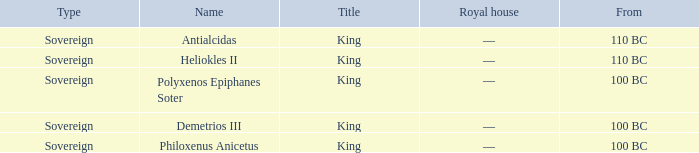When did Philoxenus Anicetus begin to hold power? 100 BC. Can you parse all the data within this table? {'header': ['Type', 'Name', 'Title', 'Royal house', 'From'], 'rows': [['Sovereign', 'Antialcidas', 'King', '—', '110 BC'], ['Sovereign', 'Heliokles II', 'King', '—', '110 BC'], ['Sovereign', 'Polyxenos Epiphanes Soter', 'King', '—', '100 BC'], ['Sovereign', 'Demetrios III', 'King', '—', '100 BC'], ['Sovereign', 'Philoxenus Anicetus', 'King', '—', '100 BC']]} 